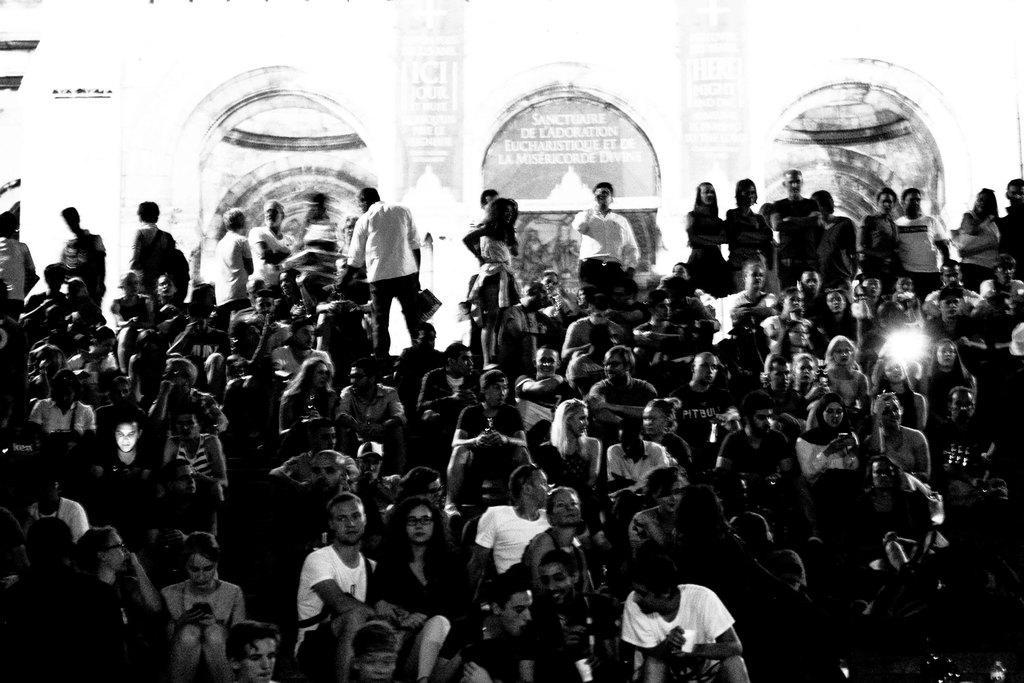Can you describe this image briefly? There is group of persons in different color dresses, sitting on the steps. On the right side, there is light. In the background, there are persons standing, near wall of the building. 